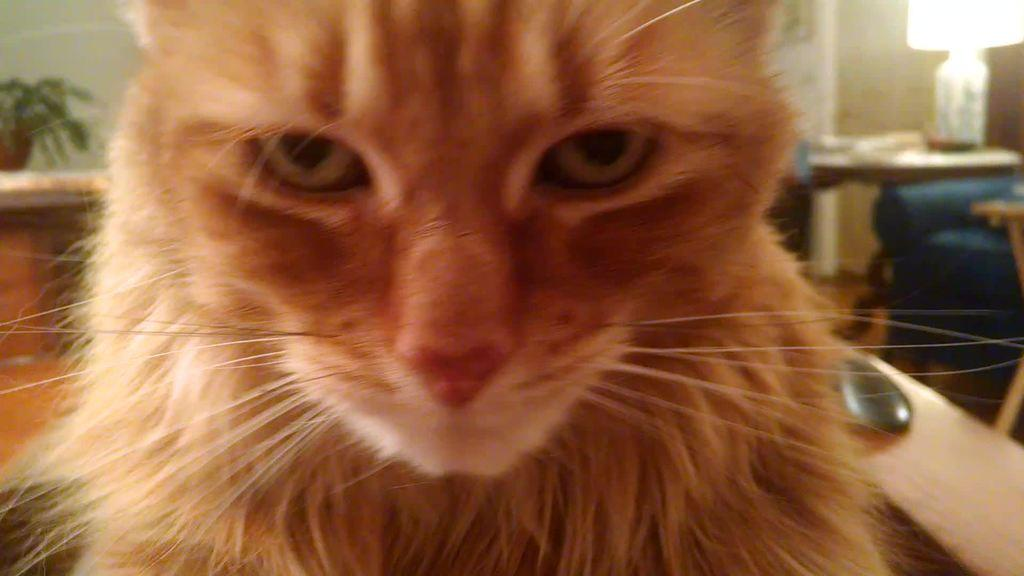What type of animal is in the image? There is a cat in the image. What color is the cat? The cat is brown in color. What furniture is present in the image? There is a table in the image, on which a lamp is placed. What type of plant container is in the image? There is a flower pot in the image. What architectural feature is visible in the image? There is a wall in the image. What type of waves can be seen crashing against the shore in the image? There are no waves or shore visible in the image; it features a cat, a lamp, a table, a flower pot, and a wall. 